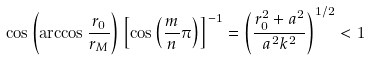<formula> <loc_0><loc_0><loc_500><loc_500>\cos \left ( \arccos \frac { r _ { 0 } } { r _ { M } } \right ) \left [ \cos \left ( \frac { m } { n } \pi \right ) \right ] ^ { - 1 } = \left ( \frac { r _ { 0 } ^ { 2 } + a ^ { 2 } } { a ^ { 2 } k ^ { 2 } } \right ) ^ { 1 / 2 } < 1</formula> 